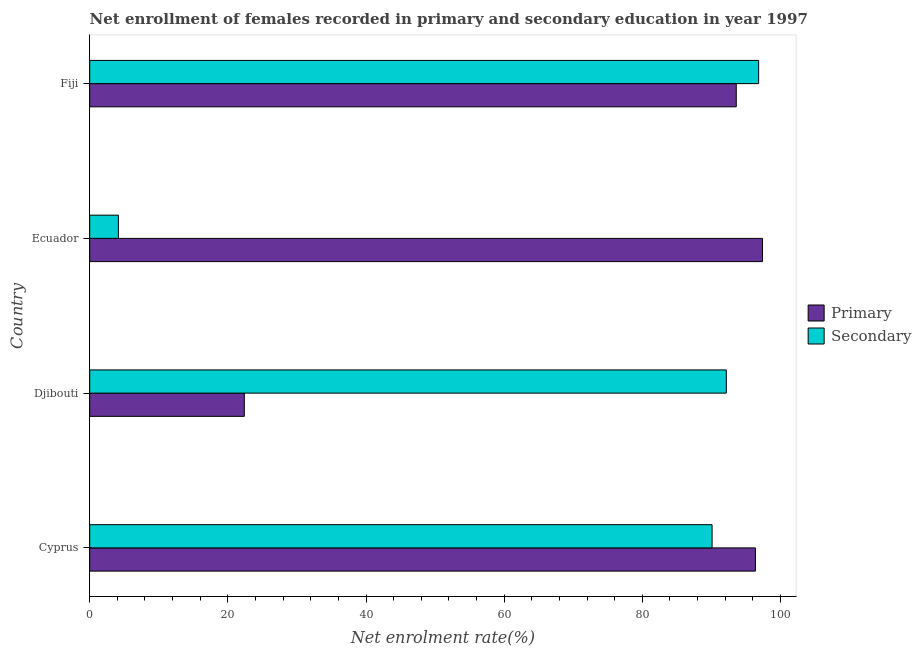How many different coloured bars are there?
Give a very brief answer. 2. How many groups of bars are there?
Make the answer very short. 4. Are the number of bars per tick equal to the number of legend labels?
Your response must be concise. Yes. How many bars are there on the 4th tick from the top?
Provide a succinct answer. 2. How many bars are there on the 1st tick from the bottom?
Provide a short and direct response. 2. What is the label of the 4th group of bars from the top?
Your answer should be very brief. Cyprus. In how many cases, is the number of bars for a given country not equal to the number of legend labels?
Your answer should be compact. 0. What is the enrollment rate in primary education in Fiji?
Provide a succinct answer. 93.6. Across all countries, what is the maximum enrollment rate in primary education?
Ensure brevity in your answer.  97.4. Across all countries, what is the minimum enrollment rate in secondary education?
Offer a very short reply. 4.16. In which country was the enrollment rate in primary education maximum?
Provide a short and direct response. Ecuador. In which country was the enrollment rate in primary education minimum?
Your response must be concise. Djibouti. What is the total enrollment rate in secondary education in the graph?
Keep it short and to the point. 283.26. What is the difference between the enrollment rate in primary education in Djibouti and that in Fiji?
Your response must be concise. -71.22. What is the difference between the enrollment rate in primary education in Fiji and the enrollment rate in secondary education in Cyprus?
Ensure brevity in your answer.  3.5. What is the average enrollment rate in secondary education per country?
Give a very brief answer. 70.81. What is the difference between the enrollment rate in primary education and enrollment rate in secondary education in Ecuador?
Make the answer very short. 93.24. What is the ratio of the enrollment rate in secondary education in Ecuador to that in Fiji?
Provide a succinct answer. 0.04. Is the enrollment rate in primary education in Djibouti less than that in Ecuador?
Offer a terse response. Yes. Is the difference between the enrollment rate in primary education in Ecuador and Fiji greater than the difference between the enrollment rate in secondary education in Ecuador and Fiji?
Provide a succinct answer. Yes. What is the difference between the highest and the second highest enrollment rate in primary education?
Your answer should be compact. 1.02. What is the difference between the highest and the lowest enrollment rate in secondary education?
Make the answer very short. 92.69. What does the 2nd bar from the top in Ecuador represents?
Ensure brevity in your answer.  Primary. What does the 1st bar from the bottom in Ecuador represents?
Your answer should be compact. Primary. How many bars are there?
Your answer should be compact. 8. How many countries are there in the graph?
Provide a short and direct response. 4. What is the difference between two consecutive major ticks on the X-axis?
Your answer should be compact. 20. Are the values on the major ticks of X-axis written in scientific E-notation?
Your answer should be compact. No. Does the graph contain any zero values?
Provide a short and direct response. No. Where does the legend appear in the graph?
Your answer should be compact. Center right. How are the legend labels stacked?
Make the answer very short. Vertical. What is the title of the graph?
Your response must be concise. Net enrollment of females recorded in primary and secondary education in year 1997. Does "Net savings(excluding particulate emission damage)" appear as one of the legend labels in the graph?
Your response must be concise. No. What is the label or title of the X-axis?
Make the answer very short. Net enrolment rate(%). What is the label or title of the Y-axis?
Provide a succinct answer. Country. What is the Net enrolment rate(%) in Primary in Cyprus?
Ensure brevity in your answer.  96.38. What is the Net enrolment rate(%) in Secondary in Cyprus?
Your answer should be very brief. 90.1. What is the Net enrolment rate(%) of Primary in Djibouti?
Offer a very short reply. 22.38. What is the Net enrolment rate(%) in Secondary in Djibouti?
Give a very brief answer. 92.16. What is the Net enrolment rate(%) in Primary in Ecuador?
Make the answer very short. 97.4. What is the Net enrolment rate(%) of Secondary in Ecuador?
Keep it short and to the point. 4.16. What is the Net enrolment rate(%) of Primary in Fiji?
Your response must be concise. 93.6. What is the Net enrolment rate(%) in Secondary in Fiji?
Keep it short and to the point. 96.84. Across all countries, what is the maximum Net enrolment rate(%) in Primary?
Give a very brief answer. 97.4. Across all countries, what is the maximum Net enrolment rate(%) in Secondary?
Give a very brief answer. 96.84. Across all countries, what is the minimum Net enrolment rate(%) in Primary?
Make the answer very short. 22.38. Across all countries, what is the minimum Net enrolment rate(%) in Secondary?
Keep it short and to the point. 4.16. What is the total Net enrolment rate(%) of Primary in the graph?
Your answer should be compact. 309.76. What is the total Net enrolment rate(%) in Secondary in the graph?
Your answer should be compact. 283.26. What is the difference between the Net enrolment rate(%) of Primary in Cyprus and that in Djibouti?
Give a very brief answer. 73.99. What is the difference between the Net enrolment rate(%) of Secondary in Cyprus and that in Djibouti?
Provide a short and direct response. -2.06. What is the difference between the Net enrolment rate(%) in Primary in Cyprus and that in Ecuador?
Make the answer very short. -1.02. What is the difference between the Net enrolment rate(%) in Secondary in Cyprus and that in Ecuador?
Your answer should be very brief. 85.94. What is the difference between the Net enrolment rate(%) in Primary in Cyprus and that in Fiji?
Your answer should be compact. 2.77. What is the difference between the Net enrolment rate(%) in Secondary in Cyprus and that in Fiji?
Offer a terse response. -6.74. What is the difference between the Net enrolment rate(%) of Primary in Djibouti and that in Ecuador?
Your response must be concise. -75.02. What is the difference between the Net enrolment rate(%) of Secondary in Djibouti and that in Ecuador?
Ensure brevity in your answer.  88.01. What is the difference between the Net enrolment rate(%) of Primary in Djibouti and that in Fiji?
Offer a terse response. -71.22. What is the difference between the Net enrolment rate(%) of Secondary in Djibouti and that in Fiji?
Provide a succinct answer. -4.68. What is the difference between the Net enrolment rate(%) of Primary in Ecuador and that in Fiji?
Keep it short and to the point. 3.8. What is the difference between the Net enrolment rate(%) of Secondary in Ecuador and that in Fiji?
Provide a short and direct response. -92.69. What is the difference between the Net enrolment rate(%) in Primary in Cyprus and the Net enrolment rate(%) in Secondary in Djibouti?
Make the answer very short. 4.21. What is the difference between the Net enrolment rate(%) of Primary in Cyprus and the Net enrolment rate(%) of Secondary in Ecuador?
Keep it short and to the point. 92.22. What is the difference between the Net enrolment rate(%) of Primary in Cyprus and the Net enrolment rate(%) of Secondary in Fiji?
Provide a short and direct response. -0.47. What is the difference between the Net enrolment rate(%) in Primary in Djibouti and the Net enrolment rate(%) in Secondary in Ecuador?
Your answer should be very brief. 18.23. What is the difference between the Net enrolment rate(%) of Primary in Djibouti and the Net enrolment rate(%) of Secondary in Fiji?
Your response must be concise. -74.46. What is the difference between the Net enrolment rate(%) of Primary in Ecuador and the Net enrolment rate(%) of Secondary in Fiji?
Keep it short and to the point. 0.56. What is the average Net enrolment rate(%) in Primary per country?
Ensure brevity in your answer.  77.44. What is the average Net enrolment rate(%) in Secondary per country?
Offer a terse response. 70.82. What is the difference between the Net enrolment rate(%) in Primary and Net enrolment rate(%) in Secondary in Cyprus?
Your answer should be very brief. 6.28. What is the difference between the Net enrolment rate(%) in Primary and Net enrolment rate(%) in Secondary in Djibouti?
Offer a very short reply. -69.78. What is the difference between the Net enrolment rate(%) in Primary and Net enrolment rate(%) in Secondary in Ecuador?
Ensure brevity in your answer.  93.24. What is the difference between the Net enrolment rate(%) of Primary and Net enrolment rate(%) of Secondary in Fiji?
Your response must be concise. -3.24. What is the ratio of the Net enrolment rate(%) of Primary in Cyprus to that in Djibouti?
Keep it short and to the point. 4.31. What is the ratio of the Net enrolment rate(%) of Secondary in Cyprus to that in Djibouti?
Keep it short and to the point. 0.98. What is the ratio of the Net enrolment rate(%) of Secondary in Cyprus to that in Ecuador?
Ensure brevity in your answer.  21.68. What is the ratio of the Net enrolment rate(%) of Primary in Cyprus to that in Fiji?
Provide a short and direct response. 1.03. What is the ratio of the Net enrolment rate(%) in Secondary in Cyprus to that in Fiji?
Keep it short and to the point. 0.93. What is the ratio of the Net enrolment rate(%) of Primary in Djibouti to that in Ecuador?
Ensure brevity in your answer.  0.23. What is the ratio of the Net enrolment rate(%) in Secondary in Djibouti to that in Ecuador?
Give a very brief answer. 22.18. What is the ratio of the Net enrolment rate(%) of Primary in Djibouti to that in Fiji?
Ensure brevity in your answer.  0.24. What is the ratio of the Net enrolment rate(%) of Secondary in Djibouti to that in Fiji?
Offer a terse response. 0.95. What is the ratio of the Net enrolment rate(%) in Primary in Ecuador to that in Fiji?
Your response must be concise. 1.04. What is the ratio of the Net enrolment rate(%) of Secondary in Ecuador to that in Fiji?
Your response must be concise. 0.04. What is the difference between the highest and the second highest Net enrolment rate(%) in Primary?
Your answer should be compact. 1.02. What is the difference between the highest and the second highest Net enrolment rate(%) of Secondary?
Offer a very short reply. 4.68. What is the difference between the highest and the lowest Net enrolment rate(%) of Primary?
Provide a short and direct response. 75.02. What is the difference between the highest and the lowest Net enrolment rate(%) of Secondary?
Your answer should be compact. 92.69. 